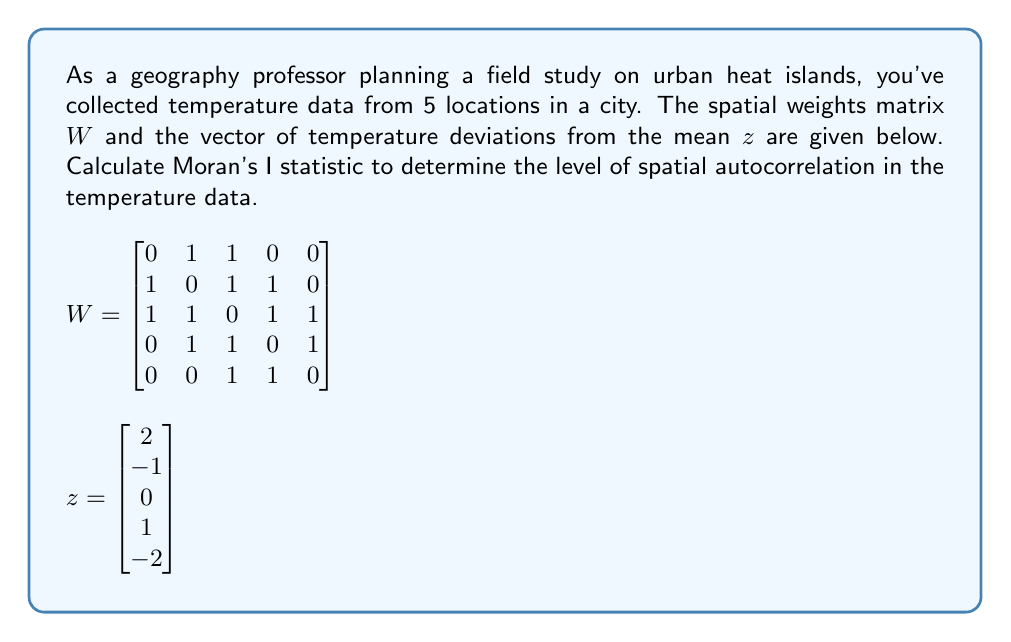Give your solution to this math problem. To calculate Moran's I statistic, we'll use the formula:

$$I = \frac{N}{W_0} \cdot \frac{\sum_{i=1}^N \sum_{j=1}^N w_{ij}(x_i - \bar{x})(x_j - \bar{x})}{\sum_{i=1}^N (x_i - \bar{x})^2}$$

Where:
- $N$ is the number of spatial units (5 in this case)
- $W_0$ is the sum of all spatial weights
- $w_{ij}$ are the elements of the spatial weights matrix W
- $x_i$ and $x_j$ are the values at locations i and j
- $\bar{x}$ is the mean of the variable

In our case, we're given z, which represents the deviations from the mean, so we can simplify our calculation.

Step 1: Calculate $W_0$
$W_0 = 1 + 1 + 1 + 1 + 1 + 1 + 1 + 1 + 1 + 1 = 10$

Step 2: Calculate the numerator
$$\sum_{i=1}^N \sum_{j=1}^N w_{ij}z_i z_j$$

We can do this by multiplying $z^T W z$:

$$\begin{bmatrix}2 & -1 & 0 & 1 & -2\end{bmatrix} 
\begin{bmatrix}
0 & 1 & 1 & 0 & 0 \\
1 & 0 & 1 & 1 & 0 \\
1 & 1 & 0 & 1 & 1 \\
0 & 1 & 1 & 0 & 1 \\
0 & 0 & 1 & 1 & 0
\end{bmatrix}
\begin{bmatrix}2 \\ -1 \\ 0 \\ 1 \\ -2\end{bmatrix}$$

$= 2(-1+0) + (-1)(2+0+1) + 0(2-1+1-2) + 1(-1+0-2) + (-2)(0+1) = -2 - 3 + 0 - 3 - 2 = -10$

Step 3: Calculate the denominator
$$\sum_{i=1}^N z_i^2 = 2^2 + (-1)^2 + 0^2 + 1^2 + (-2)^2 = 4 + 1 + 0 + 1 + 4 = 10$$

Step 4: Apply the formula
$$I = \frac{N}{W_0} \cdot \frac{\text{numerator}}{\text{denominator}} = \frac{5}{10} \cdot \frac{-10}{10} = -0.5$$
Answer: Moran's I statistic for the given data is $-0.5$, indicating negative spatial autocorrelation in the temperature data. 